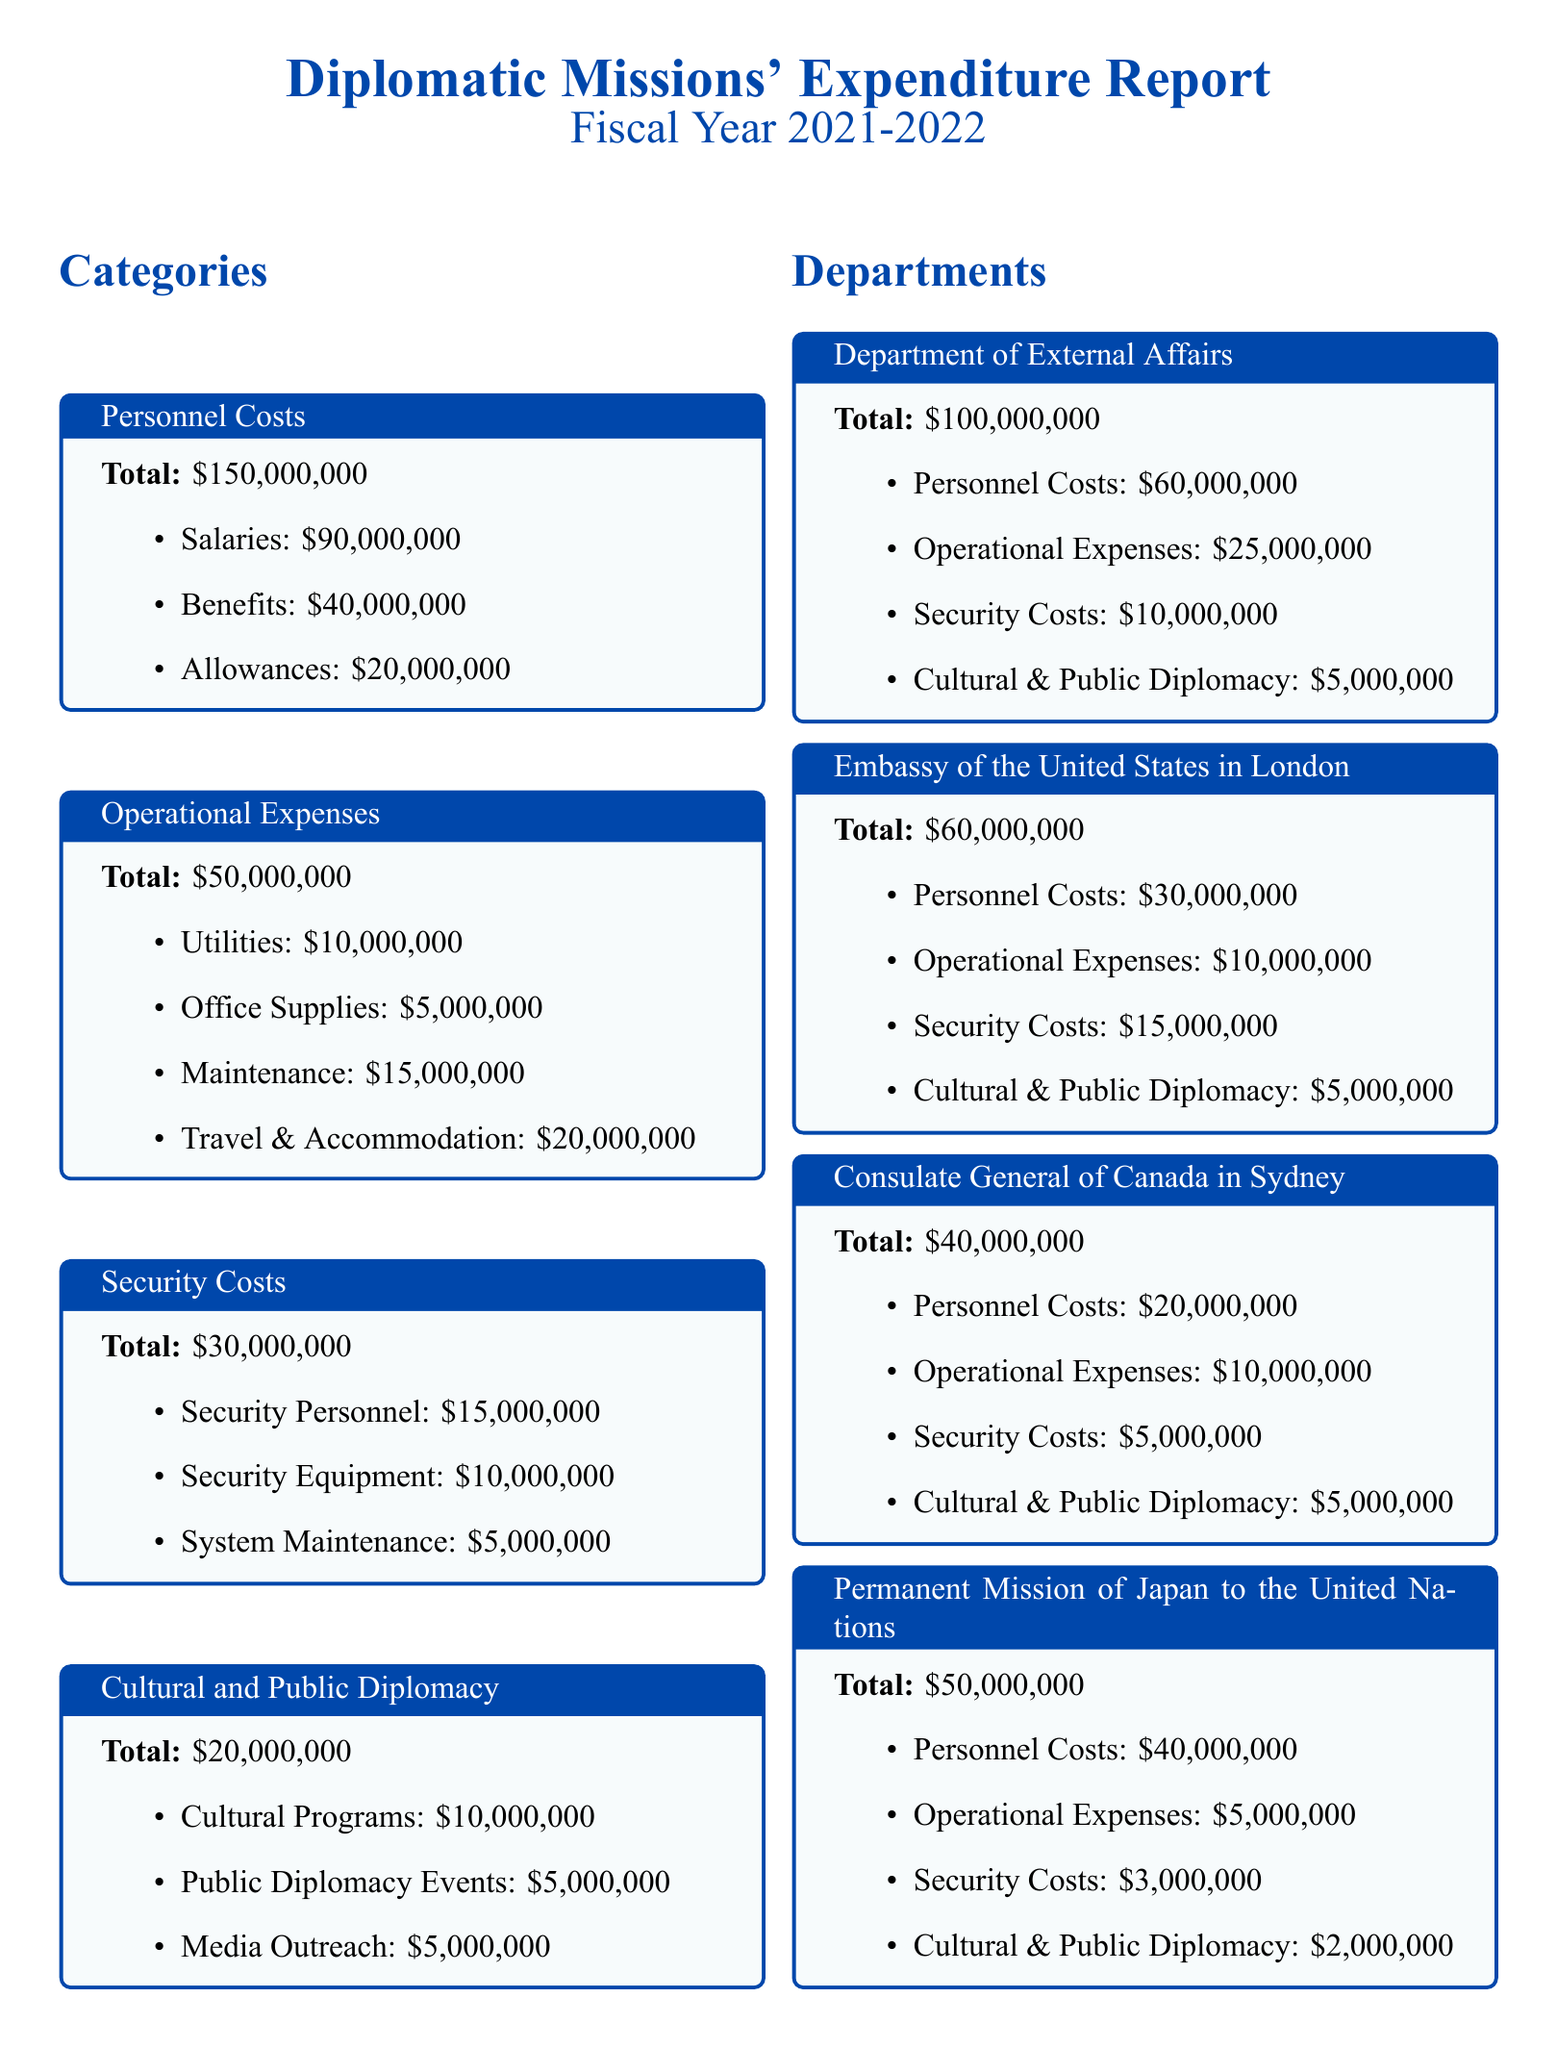what is the total expenditure on Personnel Costs? The total expenditure on Personnel Costs is stated clearly in the document as $150,000,000.
Answer: $150,000,000 how much did the Department of External Affairs spend on Security Costs? The document specifies that the Department of External Affairs allocated $10,000,000 for Security Costs.
Answer: $10,000,000 what is the total expenditure for the Embassy of the United States in London? The total expenditure for the Embassy of the United States in London is detailed in the document as $60,000,000.
Answer: $60,000,000 which category has the highest total expenditure? By reviewing the totals presented, the category with the highest expenditure is Personnel Costs with $150,000,000.
Answer: Personnel Costs how much did the Permanent Mission of Japan spend on Cultural and Public Diplomacy? The document shows that the Permanent Mission of Japan to the United Nations spent $2,000,000 on Cultural and Public Diplomacy.
Answer: $2,000,000 what is the total for Operational Expenses across all departments? The total for Operational Expenses is calculated by adding the individual totals listed under each department, equaling $25,000,000 (Department of External Affairs) + $10,000,000 (Embassy of the United States) + $10,000,000 (Consulate General of Canada) + $5,000,000 (Permanent Mission of Japan), amounting to $50,000,000.
Answer: $50,000,000 what are the total expenses for the Consulate General of Canada in Sydney? The total expenses for the Consulate General of Canada in Sydney are outlined as $40,000,000 in the document.
Answer: $40,000,000 what is the total expenditure on Security Equipment? The total expenditure specifically for Security Equipment is mentioned in the Security Costs section as $10,000,000.
Answer: $10,000,000 how much is allocated for Travel & Accommodation under Operational Expenses? The document specifies that $20,000,000 is allocated for Travel & Accommodation under Operational Expenses.
Answer: $20,000,000 